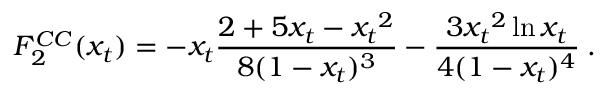<formula> <loc_0><loc_0><loc_500><loc_500>F _ { 2 } ^ { C C } ( x _ { t } ) = - x _ { t } \frac { 2 + 5 x _ { t } - { x _ { t } } ^ { 2 } } { 8 ( 1 - x _ { t } ) ^ { 3 } } - \frac { 3 { x _ { t } } ^ { 2 } \ln x _ { t } } { 4 ( 1 - x _ { t } ) ^ { 4 } } \, .</formula> 